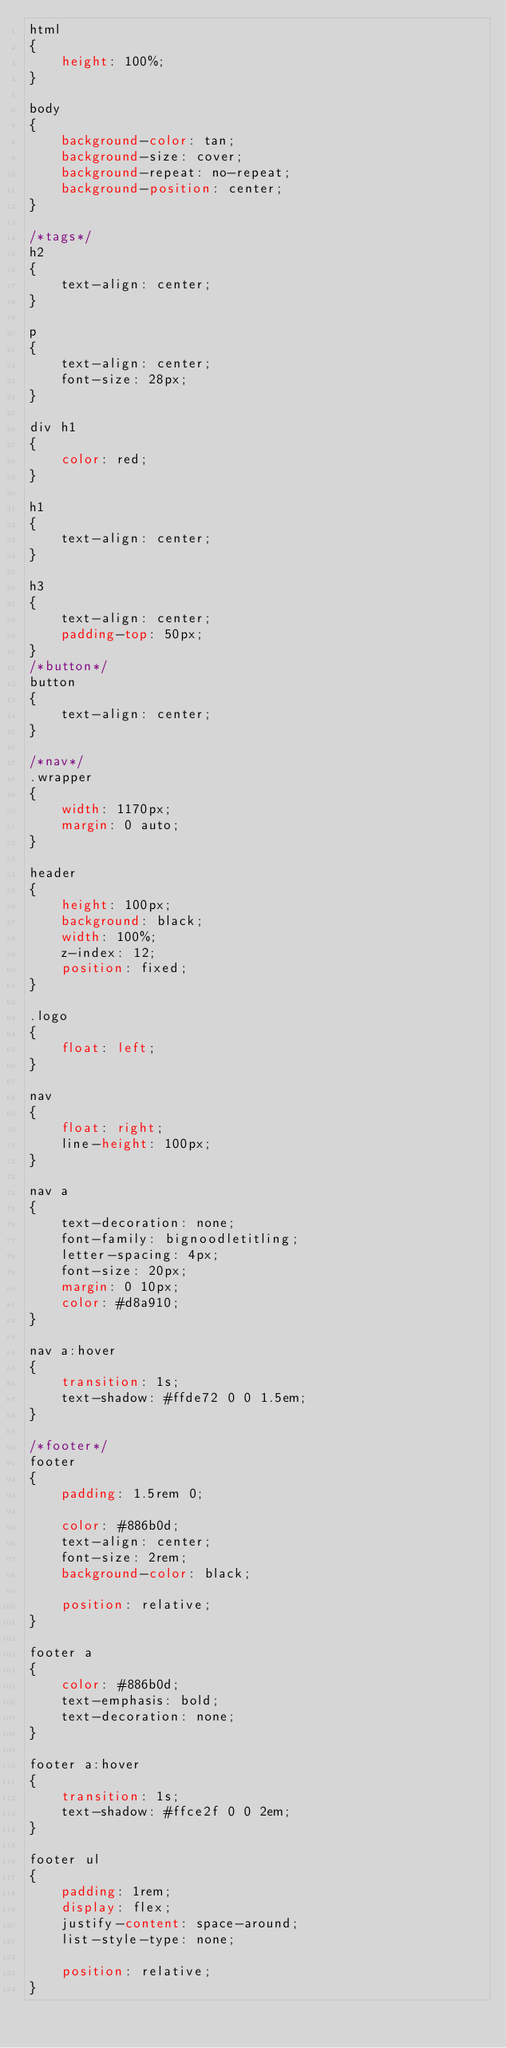Convert code to text. <code><loc_0><loc_0><loc_500><loc_500><_CSS_>html
{
	height: 100%;
}

body
{
    background-color: tan;
    background-size: cover;
    background-repeat: no-repeat;
    background-position: center;
}

/*tags*/
h2
{
	text-align: center;
}

p
{
	text-align: center;
	font-size: 28px; 
}

div h1
{
	color: red;
}

h1
{
	text-align: center;
}

h3
{
	text-align: center;
	padding-top: 50px;
}
/*button*/
button 
{
	text-align: center;
}

/*nav*/
.wrapper
{
    width: 1170px;
    margin: 0 auto;
}

header
{
    height: 100px;
    background: black;
    width: 100%;
    z-index: 12;
    position: fixed;
}

.logo
{
    float: left;
}

nav
{
    float: right;
    line-height: 100px;
}

nav a
{
    text-decoration: none;
    font-family: bignoodletitling;
    letter-spacing: 4px;
    font-size: 20px;
    margin: 0 10px;
    color: #d8a910;
}

nav a:hover
{
    transition: 1s;
    text-shadow: #ffde72 0 0 1.5em;
}

/*footer*/
footer 
{
    padding: 1.5rem 0;
    
    color: #886b0d;
    text-align: center;
    font-size: 2rem;
    background-color: black;

    position: relative;
}

footer a
{
    color: #886b0d;
    text-emphasis: bold;
    text-decoration: none;
}

footer a:hover 
{
    transition: 1s;
    text-shadow: #ffce2f 0 0 2em;
}

footer ul
{
    padding: 1rem;
    display: flex;
    justify-content: space-around;
    list-style-type: none;

    position: relative;
}
</code> 